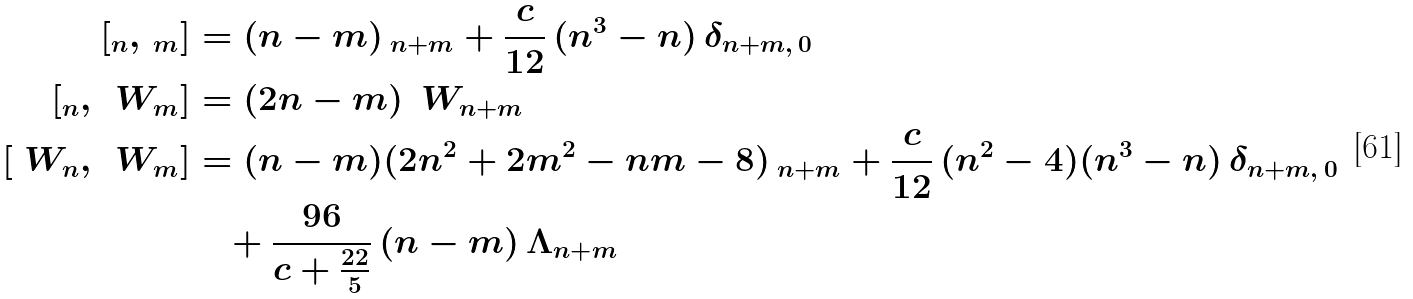Convert formula to latex. <formula><loc_0><loc_0><loc_500><loc_500>[ \L _ { n } , \, \L _ { m } ] & = ( n - m ) \, \L _ { n + m } + \frac { c } { 1 2 } \, ( n ^ { 3 } - n ) \, \delta _ { n + m , \, 0 } \\ [ \L _ { n } , \, \ W _ { m } ] & = ( 2 n - m ) \, \ W _ { n + m } \\ [ \ W _ { n } , \, \ W _ { m } ] & = ( n - m ) ( 2 n ^ { 2 } + 2 m ^ { 2 } - n m - 8 ) \, \L _ { n + m } + \frac { c } { 1 2 } \, ( n ^ { 2 } - 4 ) ( n ^ { 3 } - n ) \, \delta _ { n + m , \, 0 } \\ & \quad + \frac { 9 6 } { c + \frac { 2 2 } { 5 } } \, ( n - m ) \, \Lambda _ { n + m }</formula> 